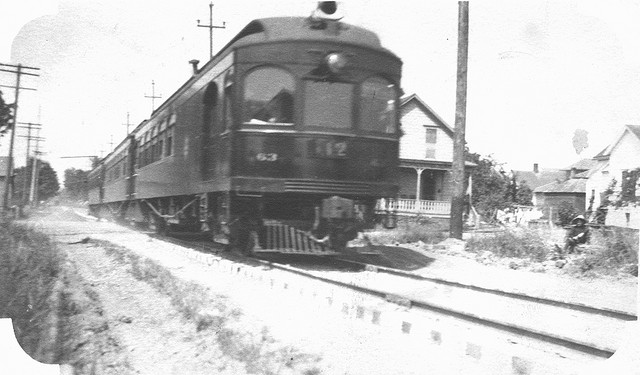Read all the text in this image. 12 